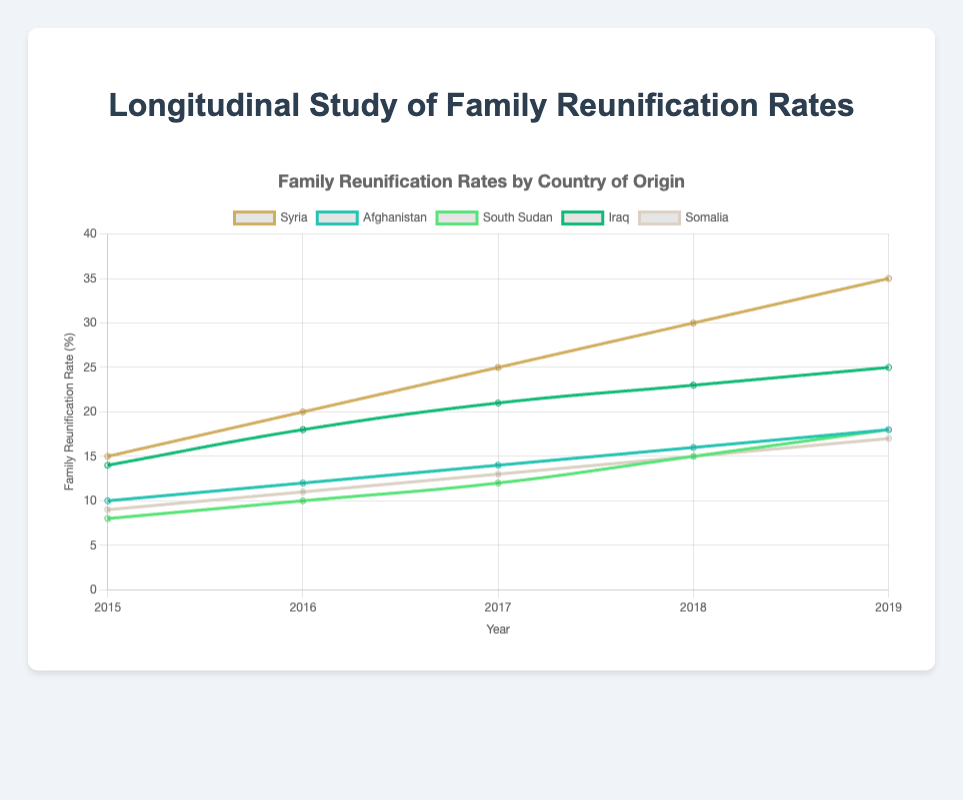Which country had the highest family reunification rate in 2019? To find the highest family reunification rate in 2019, check the plot for the data points on the lines representing different countries and identify the highest value at the year 2019.
Answer: Syria Between 2015 and 2019, which country had the most consistent increase in family reunification rates? Observe the lines corresponding to each country from 2015 to 2019 and note which lines have a steady, consistent upward trend without any sudden drops or flat segments.
Answer: Afghanistan What was the difference in the family reunification rate between Syria and Afghanistan in 2017? Look at the data points for Syria and Afghanistan in 2017, and calculate the difference between the two values. For Syria, it was 25, and for Afghanistan, it was 14. Thus, the difference is 25 - 14.
Answer: 11 Which country had the lowest family reunification rate in 2015? Identify the data points for the year 2015 for each country and note the lowest value.
Answer: South Sudan How did the average family reunification rate change from 2015 to 2019 for Iraq? Calculate the average by adding the values from 2015 to 2019 and then dividing by the number of years: (14 + 18 + 21 + 23 + 25) / 5. This gives the average for Iraq.
Answer: 20.2 Between 2017 and 2018, which country had the largest increase in family reunification rate? Check the difference in the family reunification rates for each country between 2017 and 2018, and identify the largest increase. For Syria, the difference is (30 - 25) = 5, for Afghanistan (16 - 14) = 2, for South Sudan (15 - 12) = 3, for Iraq (23 - 21) = 2, for Somalia (15 - 13) = 2.
Answer: Syria Visualize the chart and describe which countries' lines are closest to each other in 2019? Look at the lines towards the end of the chart in 2019 and notice which two lines are the most adjacent visually.
Answer: Afghanistan and South Sudan 